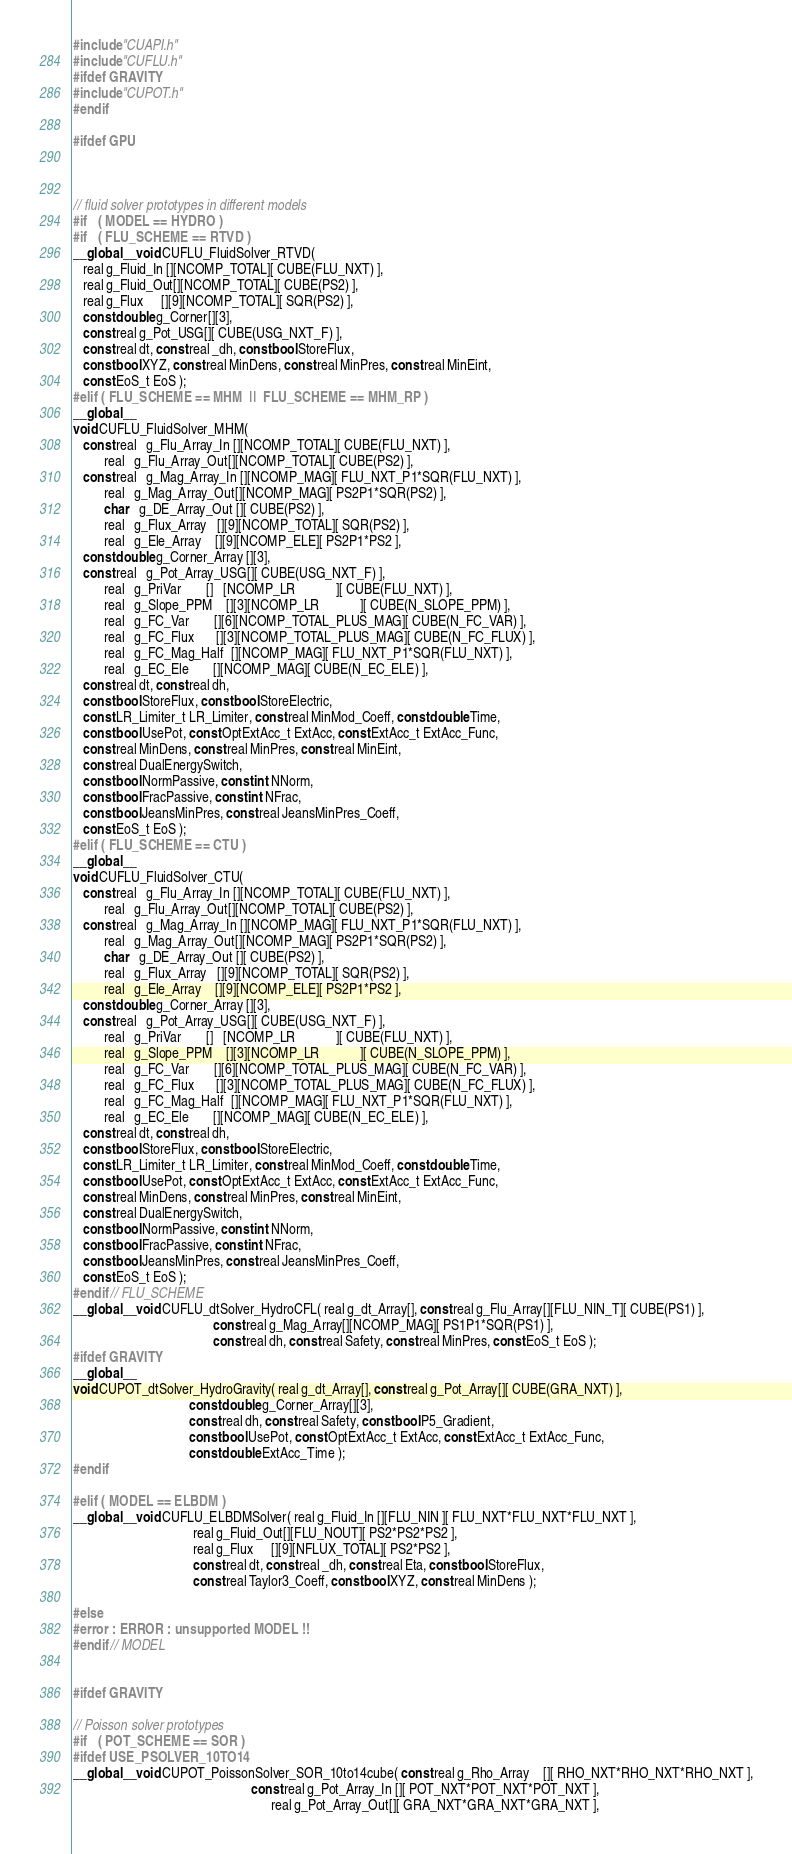Convert code to text. <code><loc_0><loc_0><loc_500><loc_500><_Cuda_>#include "CUAPI.h"
#include "CUFLU.h"
#ifdef GRAVITY
#include "CUPOT.h"
#endif

#ifdef GPU



// fluid solver prototypes in different models
#if   ( MODEL == HYDRO )
#if   ( FLU_SCHEME == RTVD )
__global__ void CUFLU_FluidSolver_RTVD(
   real g_Fluid_In [][NCOMP_TOTAL][ CUBE(FLU_NXT) ],
   real g_Fluid_Out[][NCOMP_TOTAL][ CUBE(PS2) ],
   real g_Flux     [][9][NCOMP_TOTAL][ SQR(PS2) ],
   const double g_Corner[][3],
   const real g_Pot_USG[][ CUBE(USG_NXT_F) ],
   const real dt, const real _dh, const bool StoreFlux,
   const bool XYZ, const real MinDens, const real MinPres, const real MinEint,
   const EoS_t EoS );
#elif ( FLU_SCHEME == MHM  ||  FLU_SCHEME == MHM_RP )
__global__
void CUFLU_FluidSolver_MHM(
   const real   g_Flu_Array_In [][NCOMP_TOTAL][ CUBE(FLU_NXT) ],
         real   g_Flu_Array_Out[][NCOMP_TOTAL][ CUBE(PS2) ],
   const real   g_Mag_Array_In [][NCOMP_MAG][ FLU_NXT_P1*SQR(FLU_NXT) ],
         real   g_Mag_Array_Out[][NCOMP_MAG][ PS2P1*SQR(PS2) ],
         char   g_DE_Array_Out [][ CUBE(PS2) ],
         real   g_Flux_Array   [][9][NCOMP_TOTAL][ SQR(PS2) ],
         real   g_Ele_Array    [][9][NCOMP_ELE][ PS2P1*PS2 ],
   const double g_Corner_Array [][3],
   const real   g_Pot_Array_USG[][ CUBE(USG_NXT_F) ],
         real   g_PriVar       []   [NCOMP_LR            ][ CUBE(FLU_NXT) ],
         real   g_Slope_PPM    [][3][NCOMP_LR            ][ CUBE(N_SLOPE_PPM) ],
         real   g_FC_Var       [][6][NCOMP_TOTAL_PLUS_MAG][ CUBE(N_FC_VAR) ],
         real   g_FC_Flux      [][3][NCOMP_TOTAL_PLUS_MAG][ CUBE(N_FC_FLUX) ],
         real   g_FC_Mag_Half  [][NCOMP_MAG][ FLU_NXT_P1*SQR(FLU_NXT) ],
         real   g_EC_Ele       [][NCOMP_MAG][ CUBE(N_EC_ELE) ],
   const real dt, const real dh,
   const bool StoreFlux, const bool StoreElectric,
   const LR_Limiter_t LR_Limiter, const real MinMod_Coeff, const double Time,
   const bool UsePot, const OptExtAcc_t ExtAcc, const ExtAcc_t ExtAcc_Func,
   const real MinDens, const real MinPres, const real MinEint,
   const real DualEnergySwitch,
   const bool NormPassive, const int NNorm,
   const bool FracPassive, const int NFrac,
   const bool JeansMinPres, const real JeansMinPres_Coeff,
   const EoS_t EoS );
#elif ( FLU_SCHEME == CTU )
__global__
void CUFLU_FluidSolver_CTU(
   const real   g_Flu_Array_In [][NCOMP_TOTAL][ CUBE(FLU_NXT) ],
         real   g_Flu_Array_Out[][NCOMP_TOTAL][ CUBE(PS2) ],
   const real   g_Mag_Array_In [][NCOMP_MAG][ FLU_NXT_P1*SQR(FLU_NXT) ],
         real   g_Mag_Array_Out[][NCOMP_MAG][ PS2P1*SQR(PS2) ],
         char   g_DE_Array_Out [][ CUBE(PS2) ],
         real   g_Flux_Array   [][9][NCOMP_TOTAL][ SQR(PS2) ],
         real   g_Ele_Array    [][9][NCOMP_ELE][ PS2P1*PS2 ],
   const double g_Corner_Array [][3],
   const real   g_Pot_Array_USG[][ CUBE(USG_NXT_F) ],
         real   g_PriVar       []   [NCOMP_LR            ][ CUBE(FLU_NXT) ],
         real   g_Slope_PPM    [][3][NCOMP_LR            ][ CUBE(N_SLOPE_PPM) ],
         real   g_FC_Var       [][6][NCOMP_TOTAL_PLUS_MAG][ CUBE(N_FC_VAR) ],
         real   g_FC_Flux      [][3][NCOMP_TOTAL_PLUS_MAG][ CUBE(N_FC_FLUX) ],
         real   g_FC_Mag_Half  [][NCOMP_MAG][ FLU_NXT_P1*SQR(FLU_NXT) ],
         real   g_EC_Ele       [][NCOMP_MAG][ CUBE(N_EC_ELE) ],
   const real dt, const real dh,
   const bool StoreFlux, const bool StoreElectric,
   const LR_Limiter_t LR_Limiter, const real MinMod_Coeff, const double Time,
   const bool UsePot, const OptExtAcc_t ExtAcc, const ExtAcc_t ExtAcc_Func,
   const real MinDens, const real MinPres, const real MinEint,
   const real DualEnergySwitch,
   const bool NormPassive, const int NNorm,
   const bool FracPassive, const int NFrac,
   const bool JeansMinPres, const real JeansMinPres_Coeff,
   const EoS_t EoS );
#endif // FLU_SCHEME
__global__ void CUFLU_dtSolver_HydroCFL( real g_dt_Array[], const real g_Flu_Array[][FLU_NIN_T][ CUBE(PS1) ],
                                         const real g_Mag_Array[][NCOMP_MAG][ PS1P1*SQR(PS1) ],
                                         const real dh, const real Safety, const real MinPres, const EoS_t EoS );
#ifdef GRAVITY
__global__
void CUPOT_dtSolver_HydroGravity( real g_dt_Array[], const real g_Pot_Array[][ CUBE(GRA_NXT) ],
                                  const double g_Corner_Array[][3],
                                  const real dh, const real Safety, const bool P5_Gradient,
                                  const bool UsePot, const OptExtAcc_t ExtAcc, const ExtAcc_t ExtAcc_Func,
                                  const double ExtAcc_Time );
#endif

#elif ( MODEL == ELBDM )
__global__ void CUFLU_ELBDMSolver( real g_Fluid_In [][FLU_NIN ][ FLU_NXT*FLU_NXT*FLU_NXT ],
                                   real g_Fluid_Out[][FLU_NOUT][ PS2*PS2*PS2 ],
                                   real g_Flux     [][9][NFLUX_TOTAL][ PS2*PS2 ],
                                   const real dt, const real _dh, const real Eta, const bool StoreFlux,
                                   const real Taylor3_Coeff, const bool XYZ, const real MinDens );

#else
#error : ERROR : unsupported MODEL !!
#endif // MODEL


#ifdef GRAVITY

// Poisson solver prototypes
#if   ( POT_SCHEME == SOR )
#ifdef USE_PSOLVER_10TO14
__global__ void CUPOT_PoissonSolver_SOR_10to14cube( const real g_Rho_Array    [][ RHO_NXT*RHO_NXT*RHO_NXT ],
                                                    const real g_Pot_Array_In [][ POT_NXT*POT_NXT*POT_NXT ],
                                                          real g_Pot_Array_Out[][ GRA_NXT*GRA_NXT*GRA_NXT ],</code> 